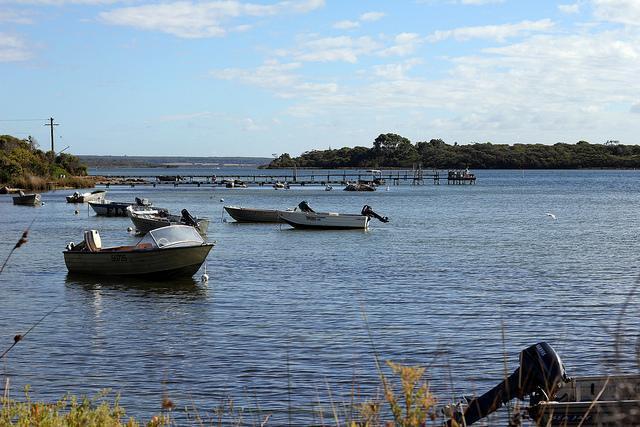How many boats can be seen?
Give a very brief answer. 2. 